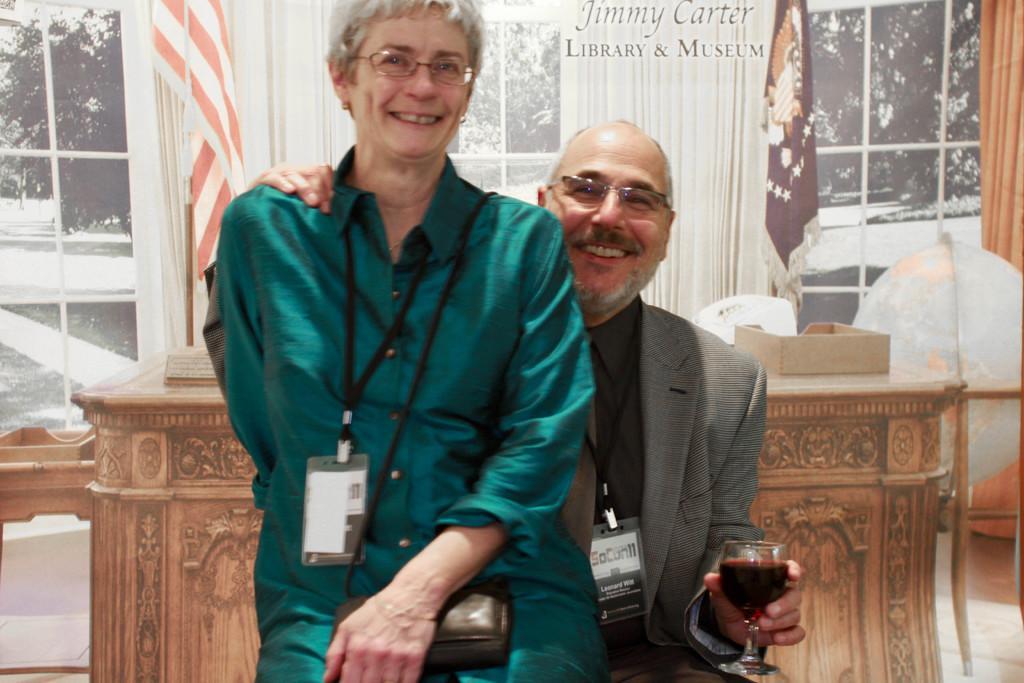Can you describe this image briefly? In the picture there are two people , one woman and one man, the woman is sitting above the man she is smiling, she is wearing green color dress and an id card , behind the the woman the man is wearing grey color coat and id card he is smiling , he is holding drink in his left hand , behind them there is a table in the background there is a a poster of a window and some flags. 